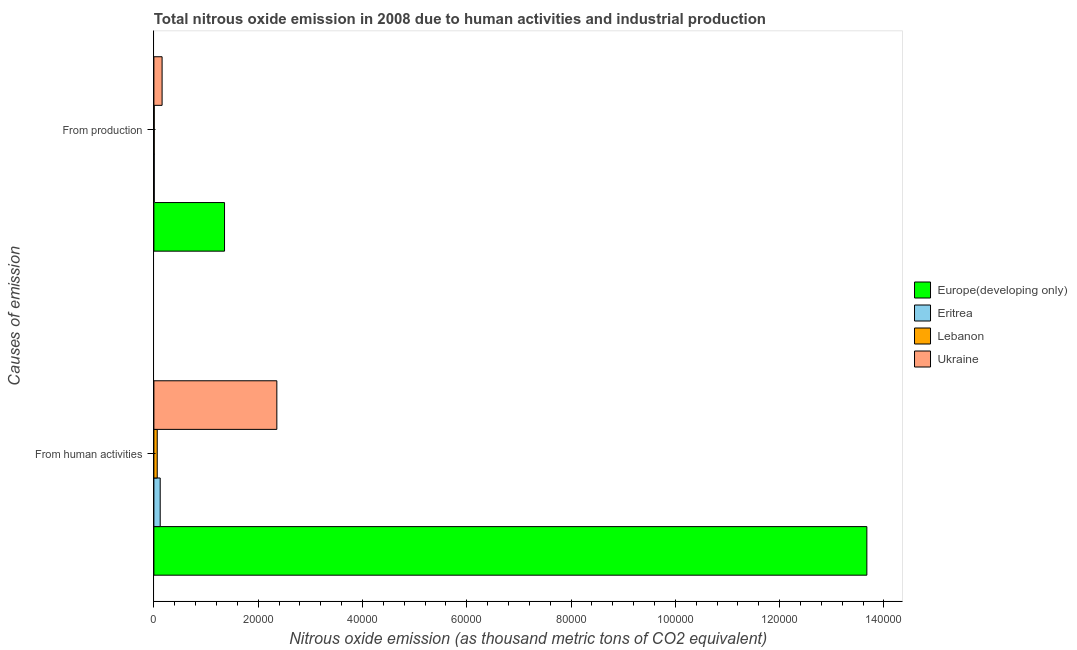How many groups of bars are there?
Ensure brevity in your answer.  2. Are the number of bars on each tick of the Y-axis equal?
Keep it short and to the point. Yes. How many bars are there on the 2nd tick from the top?
Make the answer very short. 4. What is the label of the 2nd group of bars from the top?
Offer a terse response. From human activities. What is the amount of emissions from human activities in Europe(developing only)?
Provide a succinct answer. 1.37e+05. Across all countries, what is the maximum amount of emissions from human activities?
Provide a succinct answer. 1.37e+05. Across all countries, what is the minimum amount of emissions generated from industries?
Ensure brevity in your answer.  68. In which country was the amount of emissions generated from industries maximum?
Your response must be concise. Europe(developing only). In which country was the amount of emissions from human activities minimum?
Keep it short and to the point. Lebanon. What is the total amount of emissions generated from industries in the graph?
Offer a very short reply. 1.53e+04. What is the difference between the amount of emissions generated from industries in Europe(developing only) and that in Eritrea?
Give a very brief answer. 1.35e+04. What is the difference between the amount of emissions from human activities in Eritrea and the amount of emissions generated from industries in Europe(developing only)?
Your response must be concise. -1.23e+04. What is the average amount of emissions generated from industries per country?
Provide a short and direct response. 3815.1. What is the difference between the amount of emissions generated from industries and amount of emissions from human activities in Lebanon?
Provide a short and direct response. -573.6. What is the ratio of the amount of emissions generated from industries in Ukraine to that in Europe(developing only)?
Give a very brief answer. 0.12. In how many countries, is the amount of emissions from human activities greater than the average amount of emissions from human activities taken over all countries?
Provide a succinct answer. 1. What does the 3rd bar from the top in From production represents?
Offer a very short reply. Eritrea. What does the 1st bar from the bottom in From human activities represents?
Keep it short and to the point. Europe(developing only). How many bars are there?
Give a very brief answer. 8. Are all the bars in the graph horizontal?
Provide a short and direct response. Yes. Are the values on the major ticks of X-axis written in scientific E-notation?
Your answer should be compact. No. Does the graph contain grids?
Give a very brief answer. No. What is the title of the graph?
Keep it short and to the point. Total nitrous oxide emission in 2008 due to human activities and industrial production. What is the label or title of the X-axis?
Offer a very short reply. Nitrous oxide emission (as thousand metric tons of CO2 equivalent). What is the label or title of the Y-axis?
Give a very brief answer. Causes of emission. What is the Nitrous oxide emission (as thousand metric tons of CO2 equivalent) of Europe(developing only) in From human activities?
Your response must be concise. 1.37e+05. What is the Nitrous oxide emission (as thousand metric tons of CO2 equivalent) of Eritrea in From human activities?
Offer a terse response. 1212.8. What is the Nitrous oxide emission (as thousand metric tons of CO2 equivalent) of Lebanon in From human activities?
Provide a succinct answer. 641.6. What is the Nitrous oxide emission (as thousand metric tons of CO2 equivalent) in Ukraine in From human activities?
Provide a short and direct response. 2.36e+04. What is the Nitrous oxide emission (as thousand metric tons of CO2 equivalent) in Europe(developing only) in From production?
Your response must be concise. 1.35e+04. What is the Nitrous oxide emission (as thousand metric tons of CO2 equivalent) of Eritrea in From production?
Your answer should be very brief. 69.7. What is the Nitrous oxide emission (as thousand metric tons of CO2 equivalent) of Lebanon in From production?
Provide a succinct answer. 68. What is the Nitrous oxide emission (as thousand metric tons of CO2 equivalent) in Ukraine in From production?
Your response must be concise. 1574.7. Across all Causes of emission, what is the maximum Nitrous oxide emission (as thousand metric tons of CO2 equivalent) in Europe(developing only)?
Your response must be concise. 1.37e+05. Across all Causes of emission, what is the maximum Nitrous oxide emission (as thousand metric tons of CO2 equivalent) in Eritrea?
Offer a very short reply. 1212.8. Across all Causes of emission, what is the maximum Nitrous oxide emission (as thousand metric tons of CO2 equivalent) of Lebanon?
Offer a very short reply. 641.6. Across all Causes of emission, what is the maximum Nitrous oxide emission (as thousand metric tons of CO2 equivalent) in Ukraine?
Your answer should be very brief. 2.36e+04. Across all Causes of emission, what is the minimum Nitrous oxide emission (as thousand metric tons of CO2 equivalent) of Europe(developing only)?
Offer a very short reply. 1.35e+04. Across all Causes of emission, what is the minimum Nitrous oxide emission (as thousand metric tons of CO2 equivalent) of Eritrea?
Ensure brevity in your answer.  69.7. Across all Causes of emission, what is the minimum Nitrous oxide emission (as thousand metric tons of CO2 equivalent) in Ukraine?
Ensure brevity in your answer.  1574.7. What is the total Nitrous oxide emission (as thousand metric tons of CO2 equivalent) of Europe(developing only) in the graph?
Your response must be concise. 1.50e+05. What is the total Nitrous oxide emission (as thousand metric tons of CO2 equivalent) in Eritrea in the graph?
Keep it short and to the point. 1282.5. What is the total Nitrous oxide emission (as thousand metric tons of CO2 equivalent) in Lebanon in the graph?
Make the answer very short. 709.6. What is the total Nitrous oxide emission (as thousand metric tons of CO2 equivalent) in Ukraine in the graph?
Your answer should be very brief. 2.52e+04. What is the difference between the Nitrous oxide emission (as thousand metric tons of CO2 equivalent) of Europe(developing only) in From human activities and that in From production?
Ensure brevity in your answer.  1.23e+05. What is the difference between the Nitrous oxide emission (as thousand metric tons of CO2 equivalent) of Eritrea in From human activities and that in From production?
Offer a terse response. 1143.1. What is the difference between the Nitrous oxide emission (as thousand metric tons of CO2 equivalent) in Lebanon in From human activities and that in From production?
Ensure brevity in your answer.  573.6. What is the difference between the Nitrous oxide emission (as thousand metric tons of CO2 equivalent) of Ukraine in From human activities and that in From production?
Provide a short and direct response. 2.20e+04. What is the difference between the Nitrous oxide emission (as thousand metric tons of CO2 equivalent) in Europe(developing only) in From human activities and the Nitrous oxide emission (as thousand metric tons of CO2 equivalent) in Eritrea in From production?
Ensure brevity in your answer.  1.37e+05. What is the difference between the Nitrous oxide emission (as thousand metric tons of CO2 equivalent) of Europe(developing only) in From human activities and the Nitrous oxide emission (as thousand metric tons of CO2 equivalent) of Lebanon in From production?
Provide a succinct answer. 1.37e+05. What is the difference between the Nitrous oxide emission (as thousand metric tons of CO2 equivalent) in Europe(developing only) in From human activities and the Nitrous oxide emission (as thousand metric tons of CO2 equivalent) in Ukraine in From production?
Make the answer very short. 1.35e+05. What is the difference between the Nitrous oxide emission (as thousand metric tons of CO2 equivalent) of Eritrea in From human activities and the Nitrous oxide emission (as thousand metric tons of CO2 equivalent) of Lebanon in From production?
Offer a very short reply. 1144.8. What is the difference between the Nitrous oxide emission (as thousand metric tons of CO2 equivalent) in Eritrea in From human activities and the Nitrous oxide emission (as thousand metric tons of CO2 equivalent) in Ukraine in From production?
Your response must be concise. -361.9. What is the difference between the Nitrous oxide emission (as thousand metric tons of CO2 equivalent) in Lebanon in From human activities and the Nitrous oxide emission (as thousand metric tons of CO2 equivalent) in Ukraine in From production?
Offer a terse response. -933.1. What is the average Nitrous oxide emission (as thousand metric tons of CO2 equivalent) of Europe(developing only) per Causes of emission?
Provide a succinct answer. 7.51e+04. What is the average Nitrous oxide emission (as thousand metric tons of CO2 equivalent) in Eritrea per Causes of emission?
Offer a very short reply. 641.25. What is the average Nitrous oxide emission (as thousand metric tons of CO2 equivalent) in Lebanon per Causes of emission?
Provide a short and direct response. 354.8. What is the average Nitrous oxide emission (as thousand metric tons of CO2 equivalent) of Ukraine per Causes of emission?
Your answer should be very brief. 1.26e+04. What is the difference between the Nitrous oxide emission (as thousand metric tons of CO2 equivalent) in Europe(developing only) and Nitrous oxide emission (as thousand metric tons of CO2 equivalent) in Eritrea in From human activities?
Ensure brevity in your answer.  1.36e+05. What is the difference between the Nitrous oxide emission (as thousand metric tons of CO2 equivalent) in Europe(developing only) and Nitrous oxide emission (as thousand metric tons of CO2 equivalent) in Lebanon in From human activities?
Keep it short and to the point. 1.36e+05. What is the difference between the Nitrous oxide emission (as thousand metric tons of CO2 equivalent) of Europe(developing only) and Nitrous oxide emission (as thousand metric tons of CO2 equivalent) of Ukraine in From human activities?
Keep it short and to the point. 1.13e+05. What is the difference between the Nitrous oxide emission (as thousand metric tons of CO2 equivalent) of Eritrea and Nitrous oxide emission (as thousand metric tons of CO2 equivalent) of Lebanon in From human activities?
Your response must be concise. 571.2. What is the difference between the Nitrous oxide emission (as thousand metric tons of CO2 equivalent) of Eritrea and Nitrous oxide emission (as thousand metric tons of CO2 equivalent) of Ukraine in From human activities?
Your answer should be compact. -2.24e+04. What is the difference between the Nitrous oxide emission (as thousand metric tons of CO2 equivalent) in Lebanon and Nitrous oxide emission (as thousand metric tons of CO2 equivalent) in Ukraine in From human activities?
Your answer should be compact. -2.29e+04. What is the difference between the Nitrous oxide emission (as thousand metric tons of CO2 equivalent) in Europe(developing only) and Nitrous oxide emission (as thousand metric tons of CO2 equivalent) in Eritrea in From production?
Give a very brief answer. 1.35e+04. What is the difference between the Nitrous oxide emission (as thousand metric tons of CO2 equivalent) in Europe(developing only) and Nitrous oxide emission (as thousand metric tons of CO2 equivalent) in Lebanon in From production?
Your answer should be very brief. 1.35e+04. What is the difference between the Nitrous oxide emission (as thousand metric tons of CO2 equivalent) in Europe(developing only) and Nitrous oxide emission (as thousand metric tons of CO2 equivalent) in Ukraine in From production?
Keep it short and to the point. 1.20e+04. What is the difference between the Nitrous oxide emission (as thousand metric tons of CO2 equivalent) of Eritrea and Nitrous oxide emission (as thousand metric tons of CO2 equivalent) of Lebanon in From production?
Offer a very short reply. 1.7. What is the difference between the Nitrous oxide emission (as thousand metric tons of CO2 equivalent) of Eritrea and Nitrous oxide emission (as thousand metric tons of CO2 equivalent) of Ukraine in From production?
Your answer should be very brief. -1505. What is the difference between the Nitrous oxide emission (as thousand metric tons of CO2 equivalent) of Lebanon and Nitrous oxide emission (as thousand metric tons of CO2 equivalent) of Ukraine in From production?
Give a very brief answer. -1506.7. What is the ratio of the Nitrous oxide emission (as thousand metric tons of CO2 equivalent) in Europe(developing only) in From human activities to that in From production?
Keep it short and to the point. 10.09. What is the ratio of the Nitrous oxide emission (as thousand metric tons of CO2 equivalent) in Eritrea in From human activities to that in From production?
Provide a succinct answer. 17.4. What is the ratio of the Nitrous oxide emission (as thousand metric tons of CO2 equivalent) in Lebanon in From human activities to that in From production?
Make the answer very short. 9.44. What is the ratio of the Nitrous oxide emission (as thousand metric tons of CO2 equivalent) in Ukraine in From human activities to that in From production?
Your answer should be very brief. 14.98. What is the difference between the highest and the second highest Nitrous oxide emission (as thousand metric tons of CO2 equivalent) of Europe(developing only)?
Provide a succinct answer. 1.23e+05. What is the difference between the highest and the second highest Nitrous oxide emission (as thousand metric tons of CO2 equivalent) in Eritrea?
Ensure brevity in your answer.  1143.1. What is the difference between the highest and the second highest Nitrous oxide emission (as thousand metric tons of CO2 equivalent) in Lebanon?
Ensure brevity in your answer.  573.6. What is the difference between the highest and the second highest Nitrous oxide emission (as thousand metric tons of CO2 equivalent) of Ukraine?
Keep it short and to the point. 2.20e+04. What is the difference between the highest and the lowest Nitrous oxide emission (as thousand metric tons of CO2 equivalent) in Europe(developing only)?
Make the answer very short. 1.23e+05. What is the difference between the highest and the lowest Nitrous oxide emission (as thousand metric tons of CO2 equivalent) of Eritrea?
Provide a short and direct response. 1143.1. What is the difference between the highest and the lowest Nitrous oxide emission (as thousand metric tons of CO2 equivalent) of Lebanon?
Ensure brevity in your answer.  573.6. What is the difference between the highest and the lowest Nitrous oxide emission (as thousand metric tons of CO2 equivalent) of Ukraine?
Offer a very short reply. 2.20e+04. 